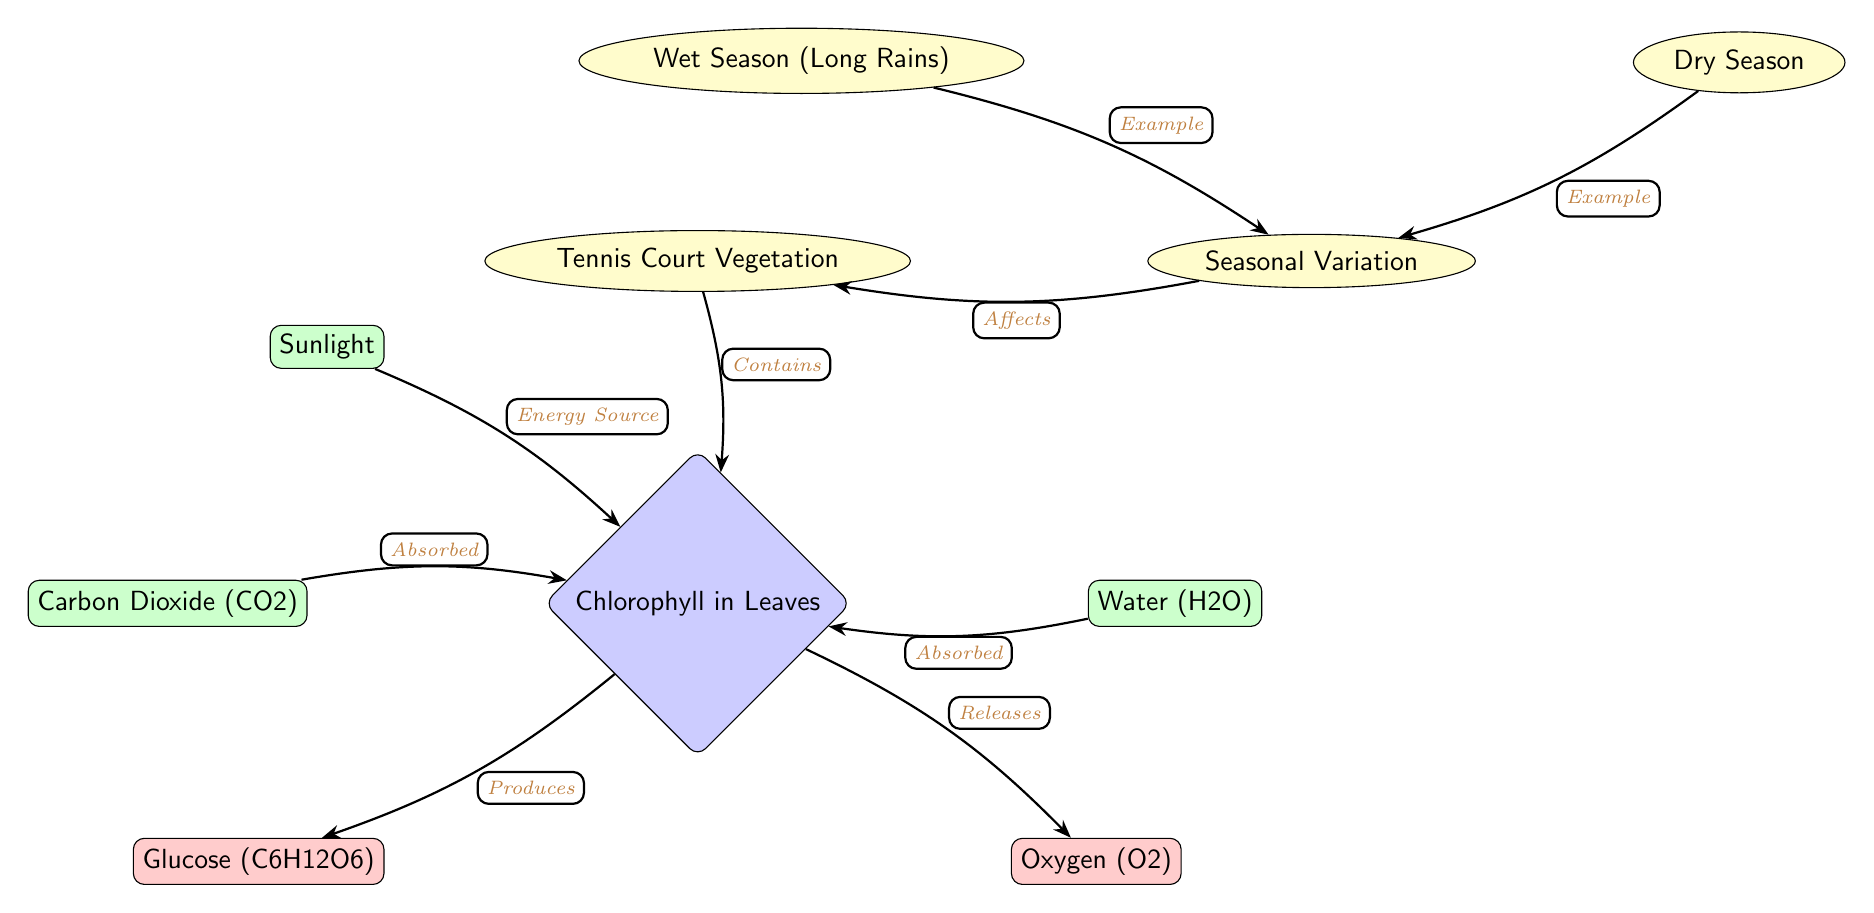What is the input that chlorophyll absorbs from the air? Chlorophyll absorbs Carbon Dioxide (CO2) from the air, as indicated by the arrow labeled "Absorbed" pointing to the chlorophyll node.
Answer: Carbon Dioxide (CO2) What are the two outputs generated by the chlorophyll process? The diagram shows that chlorophyll produces two outputs: Glucose (C6H12O6) and Oxygen (O2), both connected by arrows from the chlorophyll node.
Answer: Glucose (C6H12O6) and Oxygen (O2) How many types of seasonal variations are indicated in the diagram? The diagram lists two types of seasonal variations: Wet Season (Long Rains) and Dry Season, as shown in the seasonal variation context connected to the vegetation context.
Answer: Two What type of vegetation does the diagram refer to regarding photosynthesis? The diagram specifies "Tennis Court Vegetation" as the type of vegetation involved in photosynthesis, represented in the context node connected to chlorophyll.
Answer: Tennis Court Vegetation Which season is provided as an example of seasonal variation in the diagram? The diagram features both the Wet Season (Long Rains) and Dry Season, but if a single example is required, Wet Season is listed first in the context, hence used as an example.
Answer: Wet Season (Long Rains) 